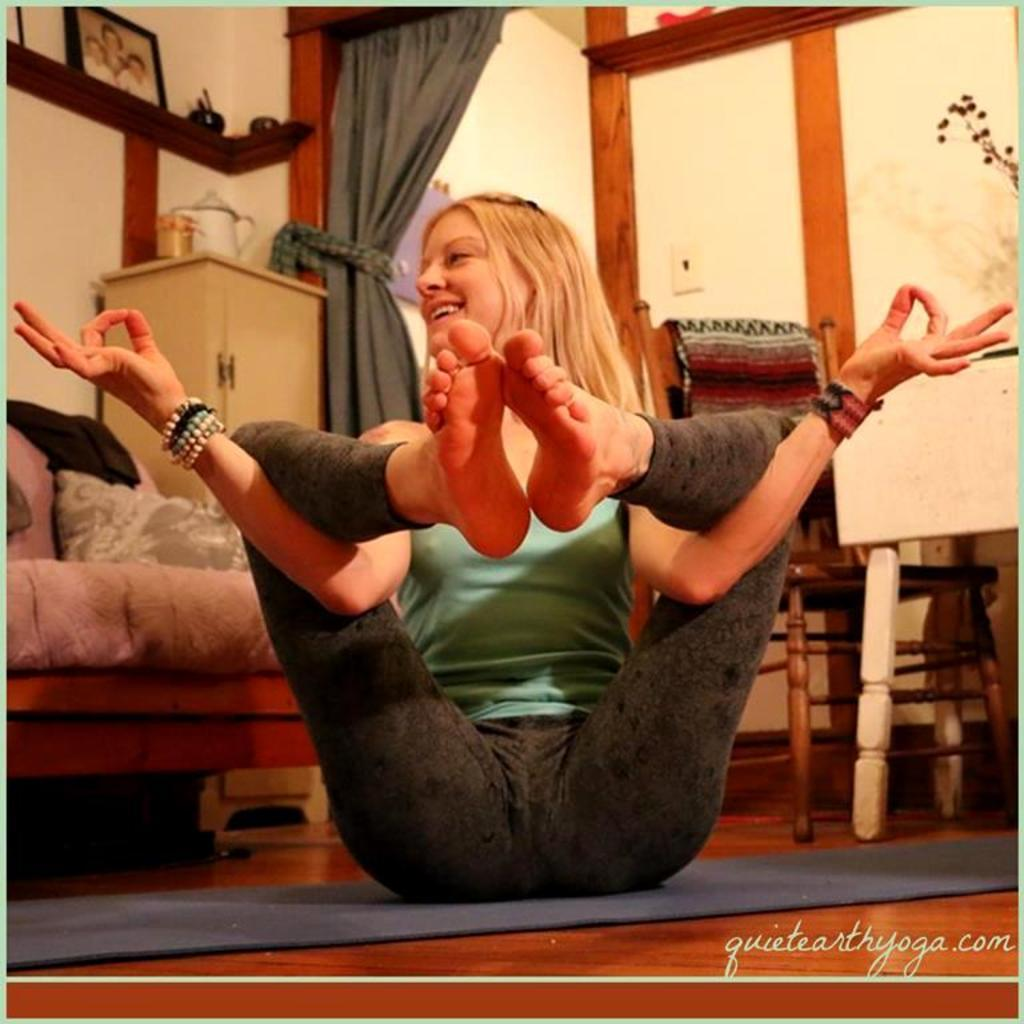What type of space is shown in the image? The image depicts a room. What is the woman in the room doing? The woman is sitting on a mat and performing exercises. What type of furniture is present in the room? There is a sofa, cushions, and a wardrobe in the room. What decorative items can be seen in the room? Photo frames and other decorative items are visible in the room. What type of window treatment is present in the room? There is a curtain in the room. What arithmetic problem is the woman solving while performing exercises in the image? There is no indication in the image that the woman is solving an arithmetic problem while exercising. How does the woman maintain her grip on the floor during the exercises? The image does not provide information about the woman's grip on the floor during the exercises. 